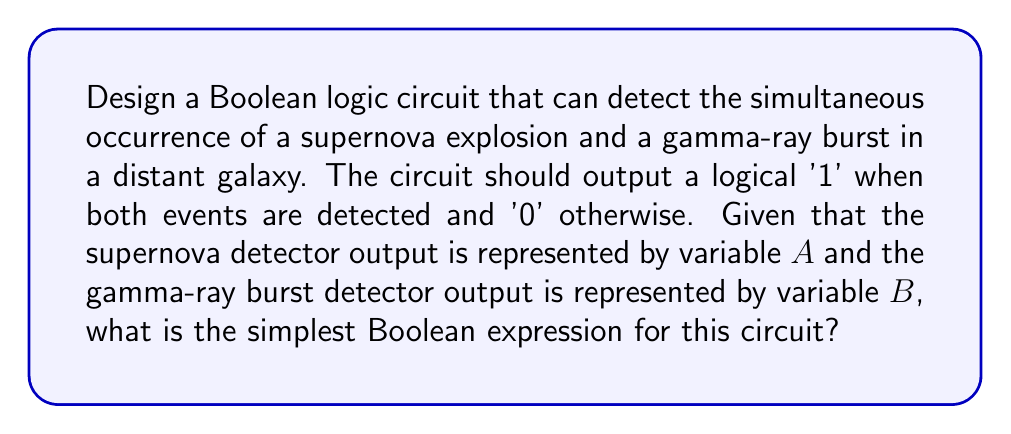Can you solve this math problem? Let's approach this step-by-step:

1) We need the circuit to output '1' only when both events are detected simultaneously. This means both $A$ and $B$ must be '1' for the output to be '1'.

2) In Boolean algebra, this scenario is represented by the AND operation, denoted by the symbol $\cdot$ or simply by writing the variables next to each other.

3) The truth table for this operation would be:

   | $A$ | $B$ | Output |
   |-----|-----|--------|
   | 0   | 0   | 0      |
   | 0   | 1   | 0      |
   | 1   | 0   | 0      |
   | 1   | 1   | 1      |

4) As we can see, the output is '1' only when both $A$ and $B$ are '1'.

5) Therefore, the Boolean expression for this circuit is simply:

   $$F = A \cdot B$$

   or equivalently:

   $$F = AB$$

6) This expression represents the simplest form of the required logic circuit, as it uses only one operation (AND) and includes both input variables without any negation or additional operations.

The corresponding logic circuit would be a single AND gate with inputs $A$ and $B$, and the output $F$.

[asy]
import geometry;

pair A = (0,1), B = (0,-1), C = (2,0);
draw(A--C--B);
draw(circle(C,0.5));
label("A", A, W);
label("B", B, W);
label("F", (3,0), E);
label("&", C, fontsize(10));
[/asy]
Answer: $F = AB$ 